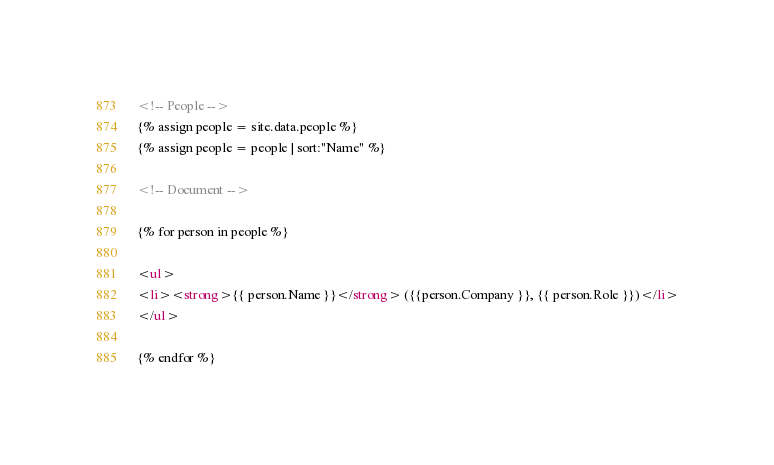<code> <loc_0><loc_0><loc_500><loc_500><_HTML_>
<!-- People -->
{% assign people = site.data.people %}
{% assign people = people | sort:"Name" %}

<!-- Document -->

{% for person in people %}

<ul>
<li><strong>{{ person.Name }}</strong> ({{person.Company }}, {{ person.Role }})</li>
</ul>

{% endfor %}

</code> 